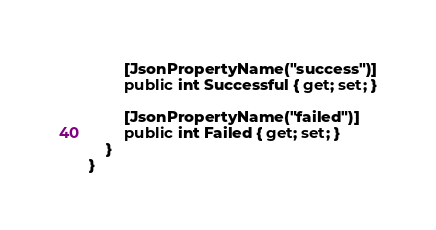<code> <loc_0><loc_0><loc_500><loc_500><_C#_>        [JsonPropertyName("success")]
        public int Successful { get; set; }

        [JsonPropertyName("failed")]
        public int Failed { get; set; }
    }
}
</code> 